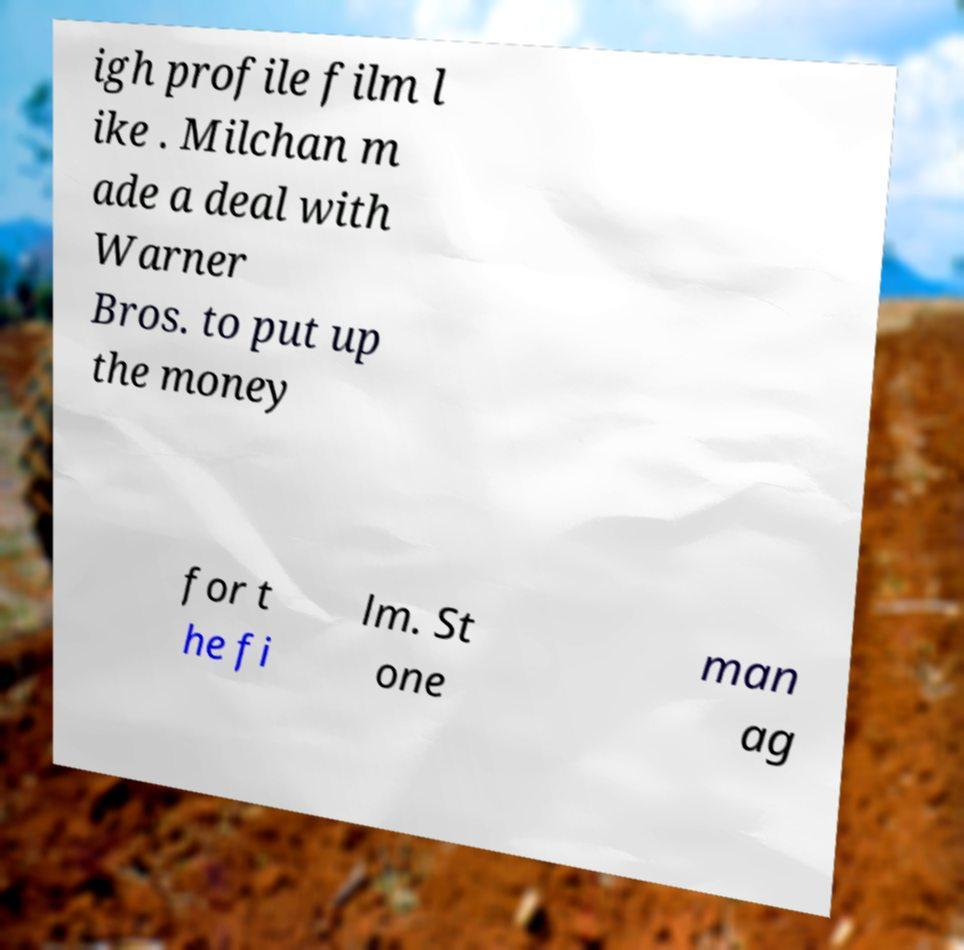Can you read and provide the text displayed in the image?This photo seems to have some interesting text. Can you extract and type it out for me? igh profile film l ike . Milchan m ade a deal with Warner Bros. to put up the money for t he fi lm. St one man ag 